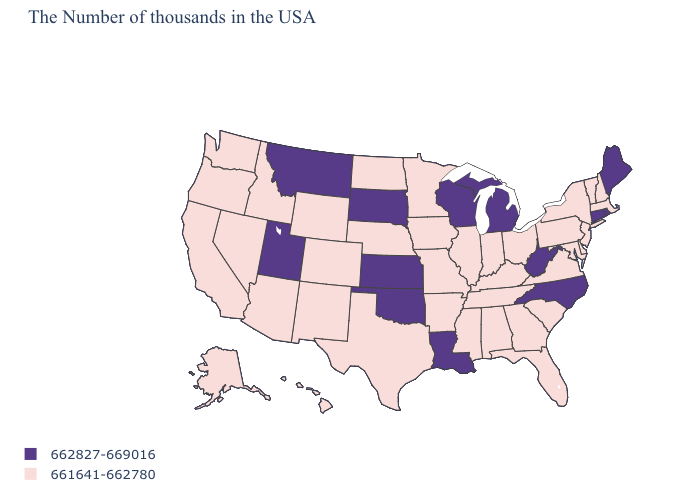Name the states that have a value in the range 662827-669016?
Quick response, please. Maine, Rhode Island, Connecticut, North Carolina, West Virginia, Michigan, Wisconsin, Louisiana, Kansas, Oklahoma, South Dakota, Utah, Montana. What is the value of Kentucky?
Quick response, please. 661641-662780. Which states have the lowest value in the USA?
Keep it brief. Massachusetts, New Hampshire, Vermont, New York, New Jersey, Delaware, Maryland, Pennsylvania, Virginia, South Carolina, Ohio, Florida, Georgia, Kentucky, Indiana, Alabama, Tennessee, Illinois, Mississippi, Missouri, Arkansas, Minnesota, Iowa, Nebraska, Texas, North Dakota, Wyoming, Colorado, New Mexico, Arizona, Idaho, Nevada, California, Washington, Oregon, Alaska, Hawaii. Name the states that have a value in the range 661641-662780?
Answer briefly. Massachusetts, New Hampshire, Vermont, New York, New Jersey, Delaware, Maryland, Pennsylvania, Virginia, South Carolina, Ohio, Florida, Georgia, Kentucky, Indiana, Alabama, Tennessee, Illinois, Mississippi, Missouri, Arkansas, Minnesota, Iowa, Nebraska, Texas, North Dakota, Wyoming, Colorado, New Mexico, Arizona, Idaho, Nevada, California, Washington, Oregon, Alaska, Hawaii. Name the states that have a value in the range 661641-662780?
Keep it brief. Massachusetts, New Hampshire, Vermont, New York, New Jersey, Delaware, Maryland, Pennsylvania, Virginia, South Carolina, Ohio, Florida, Georgia, Kentucky, Indiana, Alabama, Tennessee, Illinois, Mississippi, Missouri, Arkansas, Minnesota, Iowa, Nebraska, Texas, North Dakota, Wyoming, Colorado, New Mexico, Arizona, Idaho, Nevada, California, Washington, Oregon, Alaska, Hawaii. What is the value of New Mexico?
Give a very brief answer. 661641-662780. What is the value of Georgia?
Answer briefly. 661641-662780. What is the value of Alaska?
Answer briefly. 661641-662780. Which states have the lowest value in the Northeast?
Quick response, please. Massachusetts, New Hampshire, Vermont, New York, New Jersey, Pennsylvania. What is the value of Rhode Island?
Keep it brief. 662827-669016. Name the states that have a value in the range 662827-669016?
Quick response, please. Maine, Rhode Island, Connecticut, North Carolina, West Virginia, Michigan, Wisconsin, Louisiana, Kansas, Oklahoma, South Dakota, Utah, Montana. What is the lowest value in states that border New York?
Keep it brief. 661641-662780. Which states have the lowest value in the West?
Answer briefly. Wyoming, Colorado, New Mexico, Arizona, Idaho, Nevada, California, Washington, Oregon, Alaska, Hawaii. What is the lowest value in states that border Illinois?
Write a very short answer. 661641-662780. 